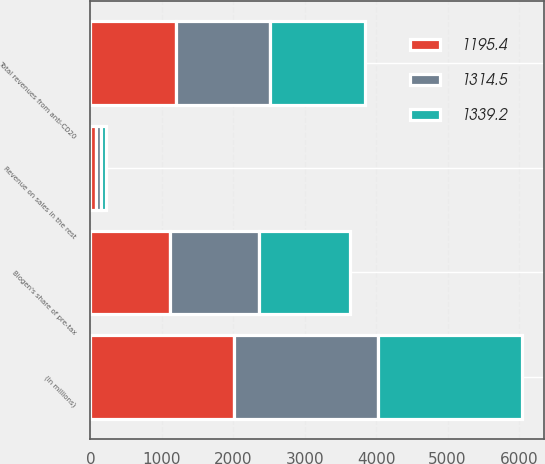Convert chart to OTSL. <chart><loc_0><loc_0><loc_500><loc_500><stacked_bar_chart><ecel><fcel>(In millions)<fcel>Biogen's share of pre-tax<fcel>Revenue on sales in the rest<fcel>Total revenues from anti-CD20<nl><fcel>1314.5<fcel>2016<fcel>1249.5<fcel>65<fcel>1314.5<nl><fcel>1339.2<fcel>2015<fcel>1269.8<fcel>69.4<fcel>1339.2<nl><fcel>1195.4<fcel>2014<fcel>1117.1<fcel>78.3<fcel>1195.4<nl></chart> 